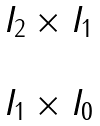<formula> <loc_0><loc_0><loc_500><loc_500>\begin{matrix} I _ { 2 } \times I _ { 1 } \\ \\ I _ { 1 } \times I _ { 0 } \end{matrix}</formula> 